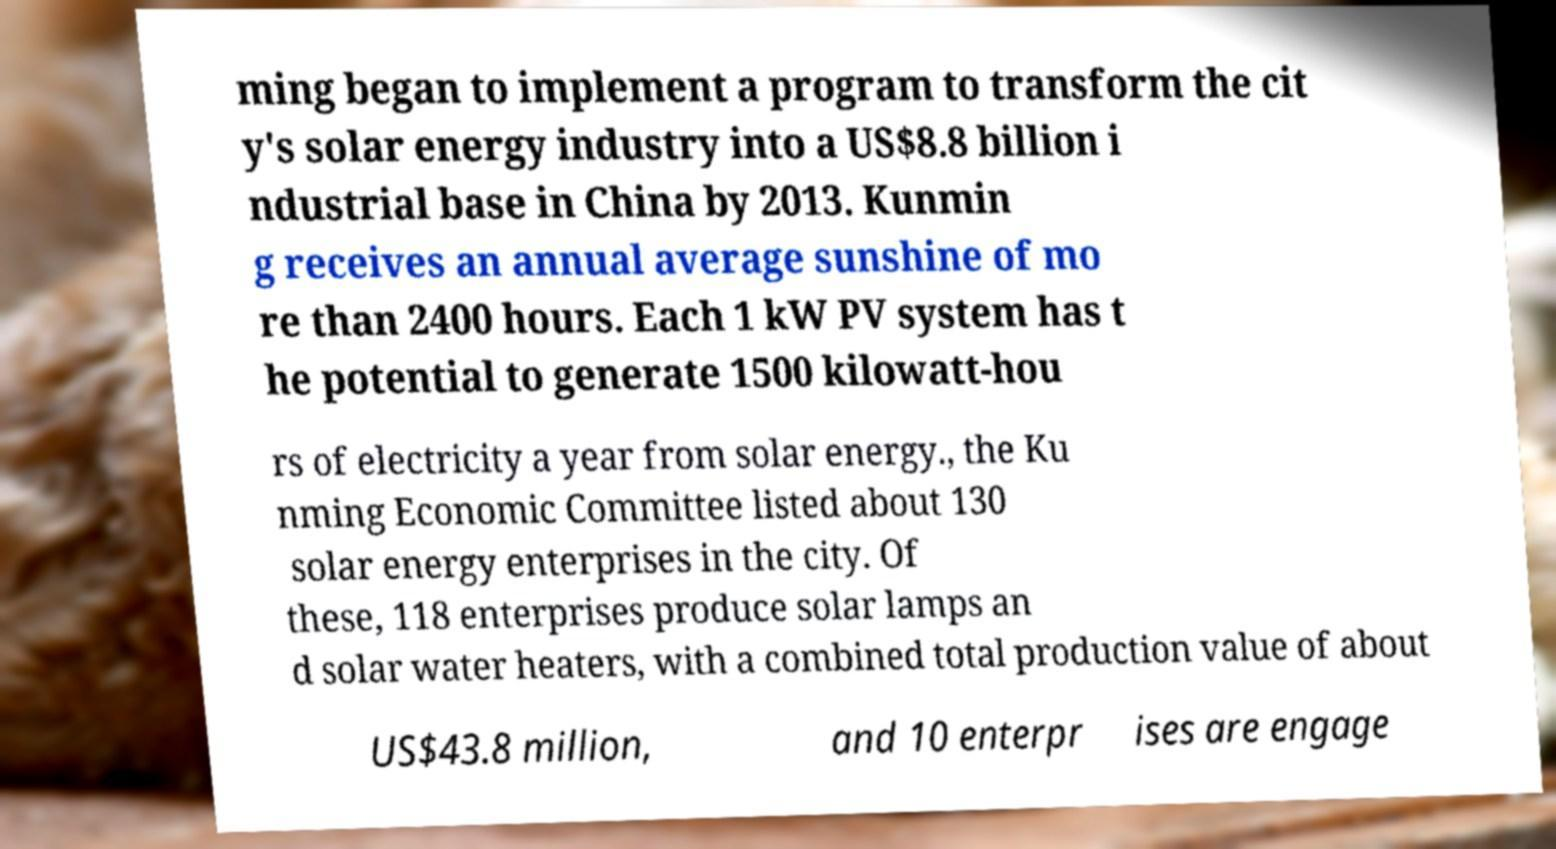What messages or text are displayed in this image? I need them in a readable, typed format. ming began to implement a program to transform the cit y's solar energy industry into a US$8.8 billion i ndustrial base in China by 2013. Kunmin g receives an annual average sunshine of mo re than 2400 hours. Each 1 kW PV system has t he potential to generate 1500 kilowatt-hou rs of electricity a year from solar energy., the Ku nming Economic Committee listed about 130 solar energy enterprises in the city. Of these, 118 enterprises produce solar lamps an d solar water heaters, with a combined total production value of about US$43.8 million, and 10 enterpr ises are engage 